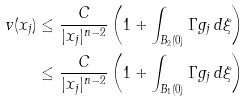<formula> <loc_0><loc_0><loc_500><loc_500>v ( x _ { j } ) & \leq \frac { C } { | x _ { j } | ^ { n - 2 } } \left ( 1 + \int _ { B _ { 2 } ( 0 ) } \Gamma g _ { j } \, d \xi \right ) \\ & \leq \frac { C } { | x _ { j } | ^ { n - 2 } } \left ( 1 + \int _ { B _ { 1 } ( 0 ) } \Gamma g _ { j } \, d \xi \right )</formula> 